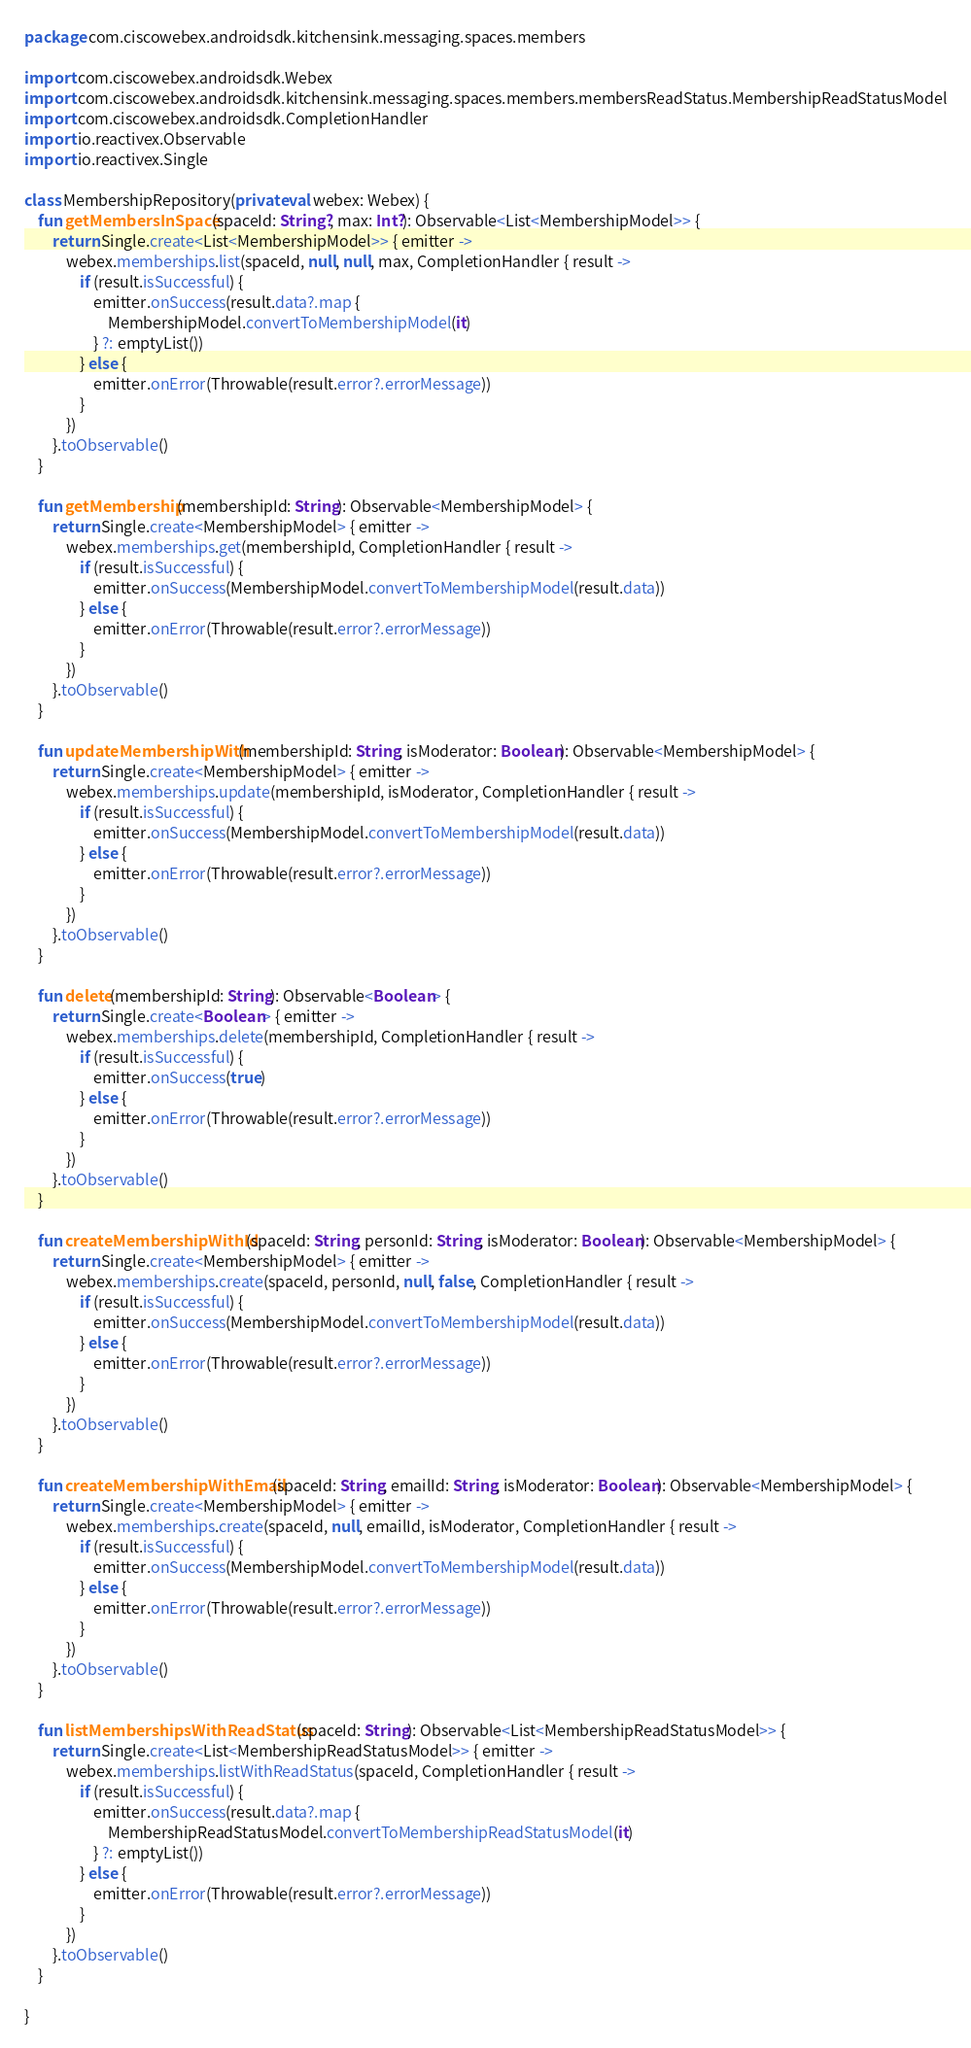Convert code to text. <code><loc_0><loc_0><loc_500><loc_500><_Kotlin_>package com.ciscowebex.androidsdk.kitchensink.messaging.spaces.members

import com.ciscowebex.androidsdk.Webex
import com.ciscowebex.androidsdk.kitchensink.messaging.spaces.members.membersReadStatus.MembershipReadStatusModel
import com.ciscowebex.androidsdk.CompletionHandler
import io.reactivex.Observable
import io.reactivex.Single

class MembershipRepository(private val webex: Webex) {
    fun getMembersInSpace(spaceId: String?, max: Int?): Observable<List<MembershipModel>> {
        return Single.create<List<MembershipModel>> { emitter ->
            webex.memberships.list(spaceId, null, null, max, CompletionHandler { result ->
                if (result.isSuccessful) {
                    emitter.onSuccess(result.data?.map {
                        MembershipModel.convertToMembershipModel(it)
                    } ?: emptyList())
                } else {
                    emitter.onError(Throwable(result.error?.errorMessage))
                }
            })
        }.toObservable()
    }

    fun getMembership(membershipId: String): Observable<MembershipModel> {
        return Single.create<MembershipModel> { emitter ->
            webex.memberships.get(membershipId, CompletionHandler { result ->
                if (result.isSuccessful) {
                    emitter.onSuccess(MembershipModel.convertToMembershipModel(result.data))
                } else {
                    emitter.onError(Throwable(result.error?.errorMessage))
                }
            })
        }.toObservable()
    }

    fun updateMembershipWith(membershipId: String, isModerator: Boolean): Observable<MembershipModel> {
        return Single.create<MembershipModel> { emitter ->
            webex.memberships.update(membershipId, isModerator, CompletionHandler { result ->
                if (result.isSuccessful) {
                    emitter.onSuccess(MembershipModel.convertToMembershipModel(result.data))
                } else {
                    emitter.onError(Throwable(result.error?.errorMessage))
                }
            })
        }.toObservable()
    }

    fun delete(membershipId: String): Observable<Boolean> {
        return Single.create<Boolean> { emitter ->
            webex.memberships.delete(membershipId, CompletionHandler { result ->
                if (result.isSuccessful) {
                    emitter.onSuccess(true)
                } else {
                    emitter.onError(Throwable(result.error?.errorMessage))
                }
            })
        }.toObservable()
    }

    fun createMembershipWithId(spaceId: String, personId: String, isModerator: Boolean): Observable<MembershipModel> {
        return Single.create<MembershipModel> { emitter ->
            webex.memberships.create(spaceId, personId, null, false, CompletionHandler { result ->
                if (result.isSuccessful) {
                    emitter.onSuccess(MembershipModel.convertToMembershipModel(result.data))
                } else {
                    emitter.onError(Throwable(result.error?.errorMessage))
                }
            })
        }.toObservable()
    }

    fun createMembershipWithEmail(spaceId: String, emailId: String, isModerator: Boolean): Observable<MembershipModel> {
        return Single.create<MembershipModel> { emitter ->
            webex.memberships.create(spaceId, null, emailId, isModerator, CompletionHandler { result ->
                if (result.isSuccessful) {
                    emitter.onSuccess(MembershipModel.convertToMembershipModel(result.data))
                } else {
                    emitter.onError(Throwable(result.error?.errorMessage))
                }
            })
        }.toObservable()
    }

    fun listMembershipsWithReadStatus(spaceId: String): Observable<List<MembershipReadStatusModel>> {
        return Single.create<List<MembershipReadStatusModel>> { emitter ->
            webex.memberships.listWithReadStatus(spaceId, CompletionHandler { result ->
                if (result.isSuccessful) {
                    emitter.onSuccess(result.data?.map {
                        MembershipReadStatusModel.convertToMembershipReadStatusModel(it)
                    } ?: emptyList())
                } else {
                    emitter.onError(Throwable(result.error?.errorMessage))
                }
            })
        }.toObservable()
    }

}</code> 